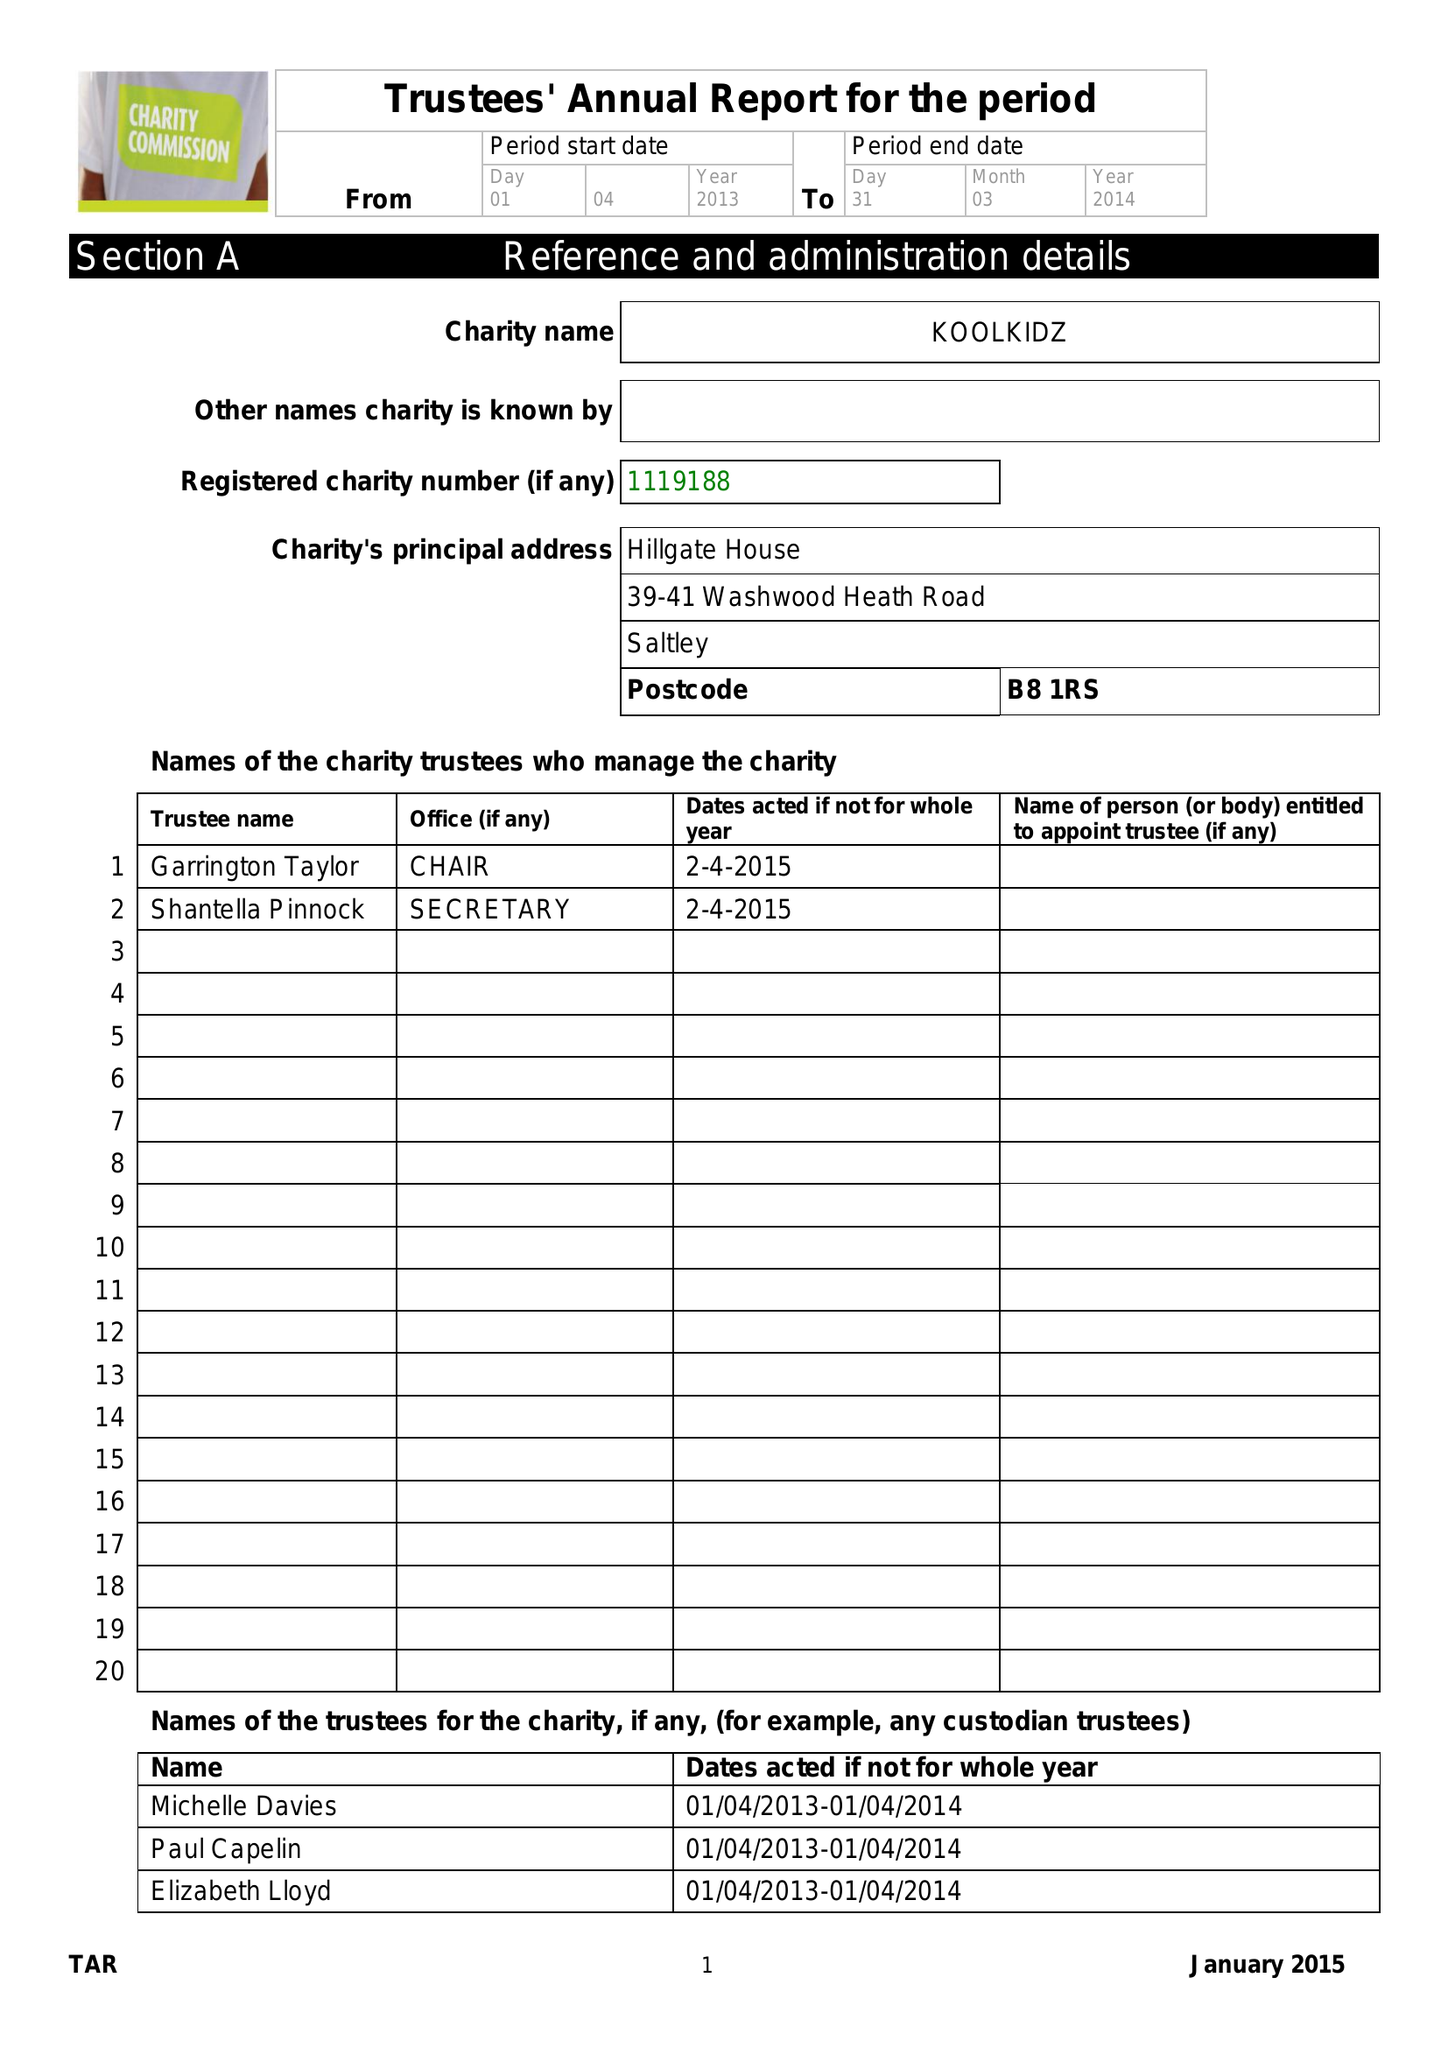What is the value for the address__street_line?
Answer the question using a single word or phrase. 39-41 WASHWOOD HEATH ROAD 